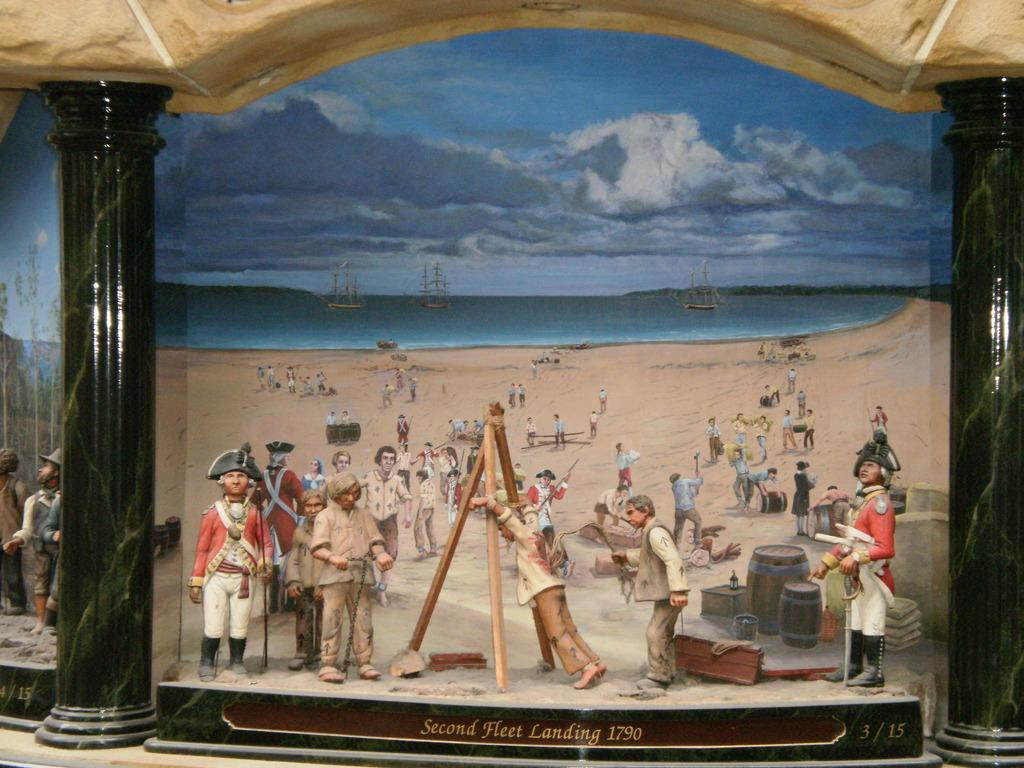<image>
Provide a brief description of the given image. A painting claims to show the second fleet landing from 1790. 